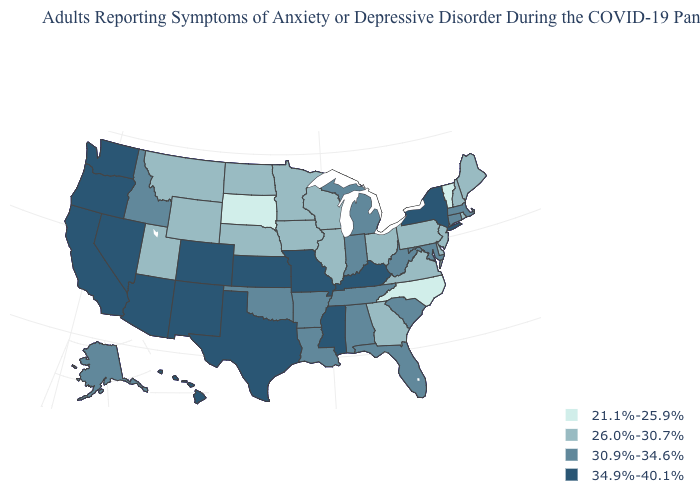Which states have the lowest value in the USA?
Be succinct. North Carolina, South Dakota, Vermont. How many symbols are there in the legend?
Write a very short answer. 4. What is the value of Michigan?
Write a very short answer. 30.9%-34.6%. Name the states that have a value in the range 30.9%-34.6%?
Keep it brief. Alabama, Alaska, Arkansas, Connecticut, Florida, Idaho, Indiana, Louisiana, Maryland, Massachusetts, Michigan, Oklahoma, South Carolina, Tennessee, West Virginia. What is the value of Virginia?
Short answer required. 26.0%-30.7%. What is the lowest value in states that border Rhode Island?
Concise answer only. 30.9%-34.6%. How many symbols are there in the legend?
Give a very brief answer. 4. Which states have the highest value in the USA?
Write a very short answer. Arizona, California, Colorado, Hawaii, Kansas, Kentucky, Mississippi, Missouri, Nevada, New Mexico, New York, Oregon, Texas, Washington. Name the states that have a value in the range 26.0%-30.7%?
Write a very short answer. Delaware, Georgia, Illinois, Iowa, Maine, Minnesota, Montana, Nebraska, New Hampshire, New Jersey, North Dakota, Ohio, Pennsylvania, Rhode Island, Utah, Virginia, Wisconsin, Wyoming. Does Tennessee have the highest value in the South?
Give a very brief answer. No. Does the map have missing data?
Keep it brief. No. What is the value of Oregon?
Keep it brief. 34.9%-40.1%. Name the states that have a value in the range 30.9%-34.6%?
Keep it brief. Alabama, Alaska, Arkansas, Connecticut, Florida, Idaho, Indiana, Louisiana, Maryland, Massachusetts, Michigan, Oklahoma, South Carolina, Tennessee, West Virginia. Does Texas have the highest value in the South?
Quick response, please. Yes. What is the value of Nebraska?
Concise answer only. 26.0%-30.7%. 